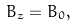Convert formula to latex. <formula><loc_0><loc_0><loc_500><loc_500>B _ { z } = B _ { 0 } ,</formula> 